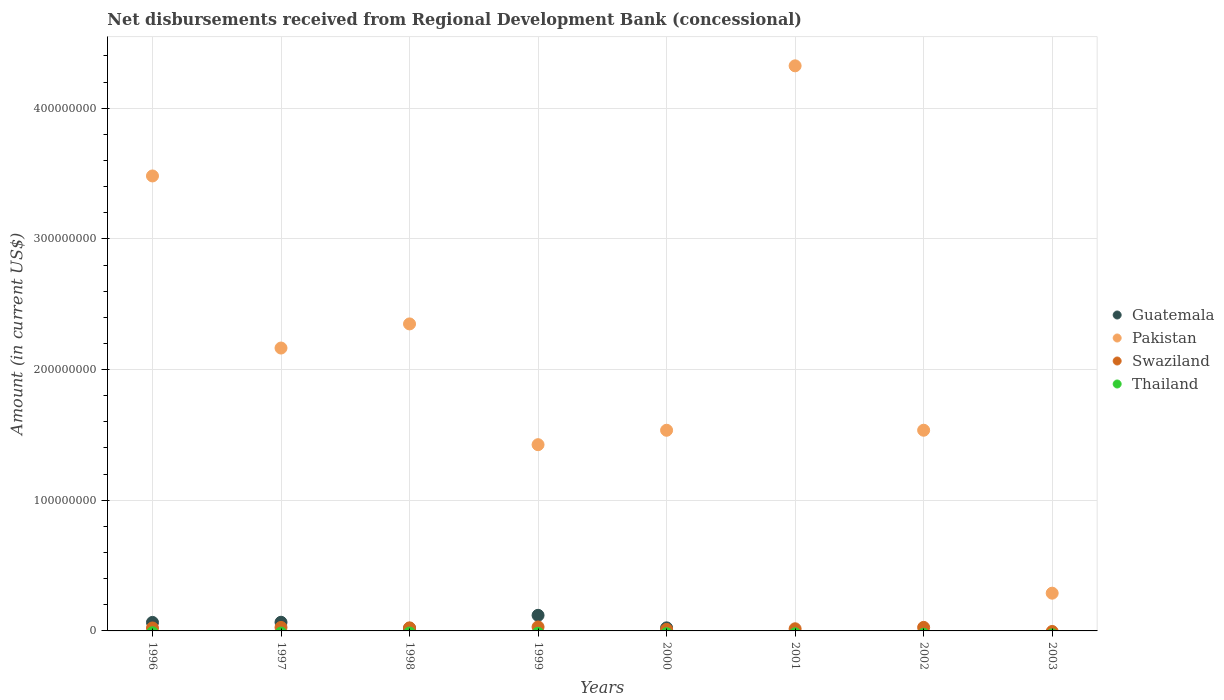How many different coloured dotlines are there?
Make the answer very short. 3. What is the amount of disbursements received from Regional Development Bank in Swaziland in 2001?
Your answer should be compact. 1.64e+06. Across all years, what is the maximum amount of disbursements received from Regional Development Bank in Pakistan?
Your answer should be compact. 4.32e+08. Across all years, what is the minimum amount of disbursements received from Regional Development Bank in Thailand?
Your response must be concise. 0. In which year was the amount of disbursements received from Regional Development Bank in Pakistan maximum?
Give a very brief answer. 2001. What is the difference between the amount of disbursements received from Regional Development Bank in Swaziland in 1996 and that in 2000?
Provide a short and direct response. 1.06e+06. What is the difference between the amount of disbursements received from Regional Development Bank in Swaziland in 1997 and the amount of disbursements received from Regional Development Bank in Pakistan in 1999?
Keep it short and to the point. -1.40e+08. In the year 1999, what is the difference between the amount of disbursements received from Regional Development Bank in Swaziland and amount of disbursements received from Regional Development Bank in Guatemala?
Your response must be concise. -8.90e+06. In how many years, is the amount of disbursements received from Regional Development Bank in Swaziland greater than 180000000 US$?
Your answer should be compact. 0. What is the ratio of the amount of disbursements received from Regional Development Bank in Pakistan in 1996 to that in 1998?
Keep it short and to the point. 1.48. Is the amount of disbursements received from Regional Development Bank in Pakistan in 1997 less than that in 2000?
Give a very brief answer. No. Is the difference between the amount of disbursements received from Regional Development Bank in Swaziland in 1996 and 1999 greater than the difference between the amount of disbursements received from Regional Development Bank in Guatemala in 1996 and 1999?
Provide a succinct answer. Yes. What is the difference between the highest and the second highest amount of disbursements received from Regional Development Bank in Swaziland?
Offer a terse response. 3.47e+05. What is the difference between the highest and the lowest amount of disbursements received from Regional Development Bank in Swaziland?
Ensure brevity in your answer.  3.04e+06. Is the sum of the amount of disbursements received from Regional Development Bank in Guatemala in 1996 and 2000 greater than the maximum amount of disbursements received from Regional Development Bank in Pakistan across all years?
Make the answer very short. No. Is the amount of disbursements received from Regional Development Bank in Thailand strictly greater than the amount of disbursements received from Regional Development Bank in Guatemala over the years?
Provide a succinct answer. No. How many dotlines are there?
Your answer should be very brief. 3. How many years are there in the graph?
Offer a very short reply. 8. Does the graph contain any zero values?
Keep it short and to the point. Yes. Where does the legend appear in the graph?
Your answer should be compact. Center right. What is the title of the graph?
Provide a succinct answer. Net disbursements received from Regional Development Bank (concessional). What is the label or title of the X-axis?
Offer a terse response. Years. What is the Amount (in current US$) in Guatemala in 1996?
Keep it short and to the point. 6.51e+06. What is the Amount (in current US$) of Pakistan in 1996?
Keep it short and to the point. 3.48e+08. What is the Amount (in current US$) in Swaziland in 1996?
Provide a short and direct response. 2.25e+06. What is the Amount (in current US$) of Guatemala in 1997?
Keep it short and to the point. 6.62e+06. What is the Amount (in current US$) in Pakistan in 1997?
Offer a very short reply. 2.16e+08. What is the Amount (in current US$) in Swaziland in 1997?
Provide a succinct answer. 2.66e+06. What is the Amount (in current US$) of Thailand in 1997?
Your answer should be compact. 0. What is the Amount (in current US$) of Guatemala in 1998?
Provide a short and direct response. 1.99e+06. What is the Amount (in current US$) in Pakistan in 1998?
Your answer should be very brief. 2.35e+08. What is the Amount (in current US$) in Swaziland in 1998?
Your answer should be compact. 2.34e+06. What is the Amount (in current US$) in Guatemala in 1999?
Offer a terse response. 1.19e+07. What is the Amount (in current US$) in Pakistan in 1999?
Provide a short and direct response. 1.43e+08. What is the Amount (in current US$) of Swaziland in 1999?
Provide a short and direct response. 3.04e+06. What is the Amount (in current US$) in Guatemala in 2000?
Offer a terse response. 2.35e+06. What is the Amount (in current US$) of Pakistan in 2000?
Provide a succinct answer. 1.54e+08. What is the Amount (in current US$) in Swaziland in 2000?
Offer a terse response. 1.19e+06. What is the Amount (in current US$) in Pakistan in 2001?
Offer a terse response. 4.32e+08. What is the Amount (in current US$) of Swaziland in 2001?
Offer a terse response. 1.64e+06. What is the Amount (in current US$) in Thailand in 2001?
Your answer should be very brief. 0. What is the Amount (in current US$) of Guatemala in 2002?
Give a very brief answer. 0. What is the Amount (in current US$) of Pakistan in 2002?
Your answer should be compact. 1.54e+08. What is the Amount (in current US$) of Swaziland in 2002?
Give a very brief answer. 2.70e+06. What is the Amount (in current US$) of Thailand in 2002?
Offer a very short reply. 0. What is the Amount (in current US$) in Pakistan in 2003?
Provide a succinct answer. 2.89e+07. What is the Amount (in current US$) in Swaziland in 2003?
Keep it short and to the point. 0. What is the Amount (in current US$) in Thailand in 2003?
Your response must be concise. 0. Across all years, what is the maximum Amount (in current US$) of Guatemala?
Provide a succinct answer. 1.19e+07. Across all years, what is the maximum Amount (in current US$) in Pakistan?
Your answer should be compact. 4.32e+08. Across all years, what is the maximum Amount (in current US$) in Swaziland?
Offer a terse response. 3.04e+06. Across all years, what is the minimum Amount (in current US$) in Pakistan?
Make the answer very short. 2.89e+07. Across all years, what is the minimum Amount (in current US$) of Swaziland?
Provide a succinct answer. 0. What is the total Amount (in current US$) of Guatemala in the graph?
Offer a very short reply. 2.94e+07. What is the total Amount (in current US$) of Pakistan in the graph?
Provide a short and direct response. 1.71e+09. What is the total Amount (in current US$) of Swaziland in the graph?
Provide a short and direct response. 1.58e+07. What is the difference between the Amount (in current US$) of Guatemala in 1996 and that in 1997?
Make the answer very short. -1.18e+05. What is the difference between the Amount (in current US$) in Pakistan in 1996 and that in 1997?
Make the answer very short. 1.32e+08. What is the difference between the Amount (in current US$) in Swaziland in 1996 and that in 1997?
Offer a terse response. -4.10e+05. What is the difference between the Amount (in current US$) of Guatemala in 1996 and that in 1998?
Your response must be concise. 4.51e+06. What is the difference between the Amount (in current US$) in Pakistan in 1996 and that in 1998?
Offer a terse response. 1.13e+08. What is the difference between the Amount (in current US$) in Swaziland in 1996 and that in 1998?
Your answer should be compact. -9.20e+04. What is the difference between the Amount (in current US$) of Guatemala in 1996 and that in 1999?
Make the answer very short. -5.44e+06. What is the difference between the Amount (in current US$) of Pakistan in 1996 and that in 1999?
Offer a terse response. 2.06e+08. What is the difference between the Amount (in current US$) of Swaziland in 1996 and that in 1999?
Provide a short and direct response. -7.90e+05. What is the difference between the Amount (in current US$) in Guatemala in 1996 and that in 2000?
Your answer should be compact. 4.16e+06. What is the difference between the Amount (in current US$) in Pakistan in 1996 and that in 2000?
Ensure brevity in your answer.  1.95e+08. What is the difference between the Amount (in current US$) of Swaziland in 1996 and that in 2000?
Keep it short and to the point. 1.06e+06. What is the difference between the Amount (in current US$) of Pakistan in 1996 and that in 2001?
Your answer should be compact. -8.43e+07. What is the difference between the Amount (in current US$) in Swaziland in 1996 and that in 2001?
Provide a succinct answer. 6.12e+05. What is the difference between the Amount (in current US$) in Pakistan in 1996 and that in 2002?
Ensure brevity in your answer.  1.95e+08. What is the difference between the Amount (in current US$) of Swaziland in 1996 and that in 2002?
Give a very brief answer. -4.43e+05. What is the difference between the Amount (in current US$) in Pakistan in 1996 and that in 2003?
Give a very brief answer. 3.19e+08. What is the difference between the Amount (in current US$) of Guatemala in 1997 and that in 1998?
Make the answer very short. 4.63e+06. What is the difference between the Amount (in current US$) of Pakistan in 1997 and that in 1998?
Your answer should be very brief. -1.85e+07. What is the difference between the Amount (in current US$) of Swaziland in 1997 and that in 1998?
Give a very brief answer. 3.18e+05. What is the difference between the Amount (in current US$) of Guatemala in 1997 and that in 1999?
Make the answer very short. -5.32e+06. What is the difference between the Amount (in current US$) of Pakistan in 1997 and that in 1999?
Provide a short and direct response. 7.40e+07. What is the difference between the Amount (in current US$) of Swaziland in 1997 and that in 1999?
Offer a terse response. -3.80e+05. What is the difference between the Amount (in current US$) of Guatemala in 1997 and that in 2000?
Your answer should be very brief. 4.28e+06. What is the difference between the Amount (in current US$) of Pakistan in 1997 and that in 2000?
Keep it short and to the point. 6.29e+07. What is the difference between the Amount (in current US$) in Swaziland in 1997 and that in 2000?
Keep it short and to the point. 1.47e+06. What is the difference between the Amount (in current US$) of Pakistan in 1997 and that in 2001?
Offer a terse response. -2.16e+08. What is the difference between the Amount (in current US$) in Swaziland in 1997 and that in 2001?
Offer a very short reply. 1.02e+06. What is the difference between the Amount (in current US$) in Pakistan in 1997 and that in 2002?
Your answer should be very brief. 6.29e+07. What is the difference between the Amount (in current US$) of Swaziland in 1997 and that in 2002?
Make the answer very short. -3.30e+04. What is the difference between the Amount (in current US$) of Pakistan in 1997 and that in 2003?
Give a very brief answer. 1.88e+08. What is the difference between the Amount (in current US$) of Guatemala in 1998 and that in 1999?
Your response must be concise. -9.95e+06. What is the difference between the Amount (in current US$) of Pakistan in 1998 and that in 1999?
Keep it short and to the point. 9.24e+07. What is the difference between the Amount (in current US$) of Swaziland in 1998 and that in 1999?
Your answer should be compact. -6.98e+05. What is the difference between the Amount (in current US$) in Guatemala in 1998 and that in 2000?
Keep it short and to the point. -3.56e+05. What is the difference between the Amount (in current US$) in Pakistan in 1998 and that in 2000?
Provide a succinct answer. 8.14e+07. What is the difference between the Amount (in current US$) of Swaziland in 1998 and that in 2000?
Give a very brief answer. 1.15e+06. What is the difference between the Amount (in current US$) in Pakistan in 1998 and that in 2001?
Your answer should be compact. -1.98e+08. What is the difference between the Amount (in current US$) of Swaziland in 1998 and that in 2001?
Offer a terse response. 7.04e+05. What is the difference between the Amount (in current US$) of Pakistan in 1998 and that in 2002?
Give a very brief answer. 8.14e+07. What is the difference between the Amount (in current US$) of Swaziland in 1998 and that in 2002?
Ensure brevity in your answer.  -3.51e+05. What is the difference between the Amount (in current US$) of Pakistan in 1998 and that in 2003?
Offer a very short reply. 2.06e+08. What is the difference between the Amount (in current US$) in Guatemala in 1999 and that in 2000?
Your response must be concise. 9.60e+06. What is the difference between the Amount (in current US$) of Pakistan in 1999 and that in 2000?
Your response must be concise. -1.10e+07. What is the difference between the Amount (in current US$) of Swaziland in 1999 and that in 2000?
Your response must be concise. 1.85e+06. What is the difference between the Amount (in current US$) in Pakistan in 1999 and that in 2001?
Ensure brevity in your answer.  -2.90e+08. What is the difference between the Amount (in current US$) of Swaziland in 1999 and that in 2001?
Make the answer very short. 1.40e+06. What is the difference between the Amount (in current US$) in Pakistan in 1999 and that in 2002?
Provide a succinct answer. -1.11e+07. What is the difference between the Amount (in current US$) of Swaziland in 1999 and that in 2002?
Offer a very short reply. 3.47e+05. What is the difference between the Amount (in current US$) of Pakistan in 1999 and that in 2003?
Your answer should be very brief. 1.14e+08. What is the difference between the Amount (in current US$) of Pakistan in 2000 and that in 2001?
Make the answer very short. -2.79e+08. What is the difference between the Amount (in current US$) of Swaziland in 2000 and that in 2001?
Give a very brief answer. -4.48e+05. What is the difference between the Amount (in current US$) in Pakistan in 2000 and that in 2002?
Ensure brevity in your answer.  -1.80e+04. What is the difference between the Amount (in current US$) in Swaziland in 2000 and that in 2002?
Give a very brief answer. -1.50e+06. What is the difference between the Amount (in current US$) in Pakistan in 2000 and that in 2003?
Your answer should be very brief. 1.25e+08. What is the difference between the Amount (in current US$) in Pakistan in 2001 and that in 2002?
Provide a succinct answer. 2.79e+08. What is the difference between the Amount (in current US$) in Swaziland in 2001 and that in 2002?
Your response must be concise. -1.06e+06. What is the difference between the Amount (in current US$) of Pakistan in 2001 and that in 2003?
Offer a very short reply. 4.04e+08. What is the difference between the Amount (in current US$) in Pakistan in 2002 and that in 2003?
Your response must be concise. 1.25e+08. What is the difference between the Amount (in current US$) in Guatemala in 1996 and the Amount (in current US$) in Pakistan in 1997?
Make the answer very short. -2.10e+08. What is the difference between the Amount (in current US$) in Guatemala in 1996 and the Amount (in current US$) in Swaziland in 1997?
Your answer should be compact. 3.84e+06. What is the difference between the Amount (in current US$) in Pakistan in 1996 and the Amount (in current US$) in Swaziland in 1997?
Keep it short and to the point. 3.46e+08. What is the difference between the Amount (in current US$) in Guatemala in 1996 and the Amount (in current US$) in Pakistan in 1998?
Provide a short and direct response. -2.28e+08. What is the difference between the Amount (in current US$) in Guatemala in 1996 and the Amount (in current US$) in Swaziland in 1998?
Keep it short and to the point. 4.16e+06. What is the difference between the Amount (in current US$) of Pakistan in 1996 and the Amount (in current US$) of Swaziland in 1998?
Your response must be concise. 3.46e+08. What is the difference between the Amount (in current US$) in Guatemala in 1996 and the Amount (in current US$) in Pakistan in 1999?
Your answer should be very brief. -1.36e+08. What is the difference between the Amount (in current US$) of Guatemala in 1996 and the Amount (in current US$) of Swaziland in 1999?
Provide a succinct answer. 3.46e+06. What is the difference between the Amount (in current US$) in Pakistan in 1996 and the Amount (in current US$) in Swaziland in 1999?
Keep it short and to the point. 3.45e+08. What is the difference between the Amount (in current US$) in Guatemala in 1996 and the Amount (in current US$) in Pakistan in 2000?
Make the answer very short. -1.47e+08. What is the difference between the Amount (in current US$) in Guatemala in 1996 and the Amount (in current US$) in Swaziland in 2000?
Offer a very short reply. 5.32e+06. What is the difference between the Amount (in current US$) in Pakistan in 1996 and the Amount (in current US$) in Swaziland in 2000?
Keep it short and to the point. 3.47e+08. What is the difference between the Amount (in current US$) in Guatemala in 1996 and the Amount (in current US$) in Pakistan in 2001?
Keep it short and to the point. -4.26e+08. What is the difference between the Amount (in current US$) in Guatemala in 1996 and the Amount (in current US$) in Swaziland in 2001?
Make the answer very short. 4.87e+06. What is the difference between the Amount (in current US$) of Pakistan in 1996 and the Amount (in current US$) of Swaziland in 2001?
Give a very brief answer. 3.47e+08. What is the difference between the Amount (in current US$) of Guatemala in 1996 and the Amount (in current US$) of Pakistan in 2002?
Make the answer very short. -1.47e+08. What is the difference between the Amount (in current US$) of Guatemala in 1996 and the Amount (in current US$) of Swaziland in 2002?
Give a very brief answer. 3.81e+06. What is the difference between the Amount (in current US$) in Pakistan in 1996 and the Amount (in current US$) in Swaziland in 2002?
Offer a very short reply. 3.45e+08. What is the difference between the Amount (in current US$) of Guatemala in 1996 and the Amount (in current US$) of Pakistan in 2003?
Offer a very short reply. -2.24e+07. What is the difference between the Amount (in current US$) of Guatemala in 1997 and the Amount (in current US$) of Pakistan in 1998?
Your answer should be compact. -2.28e+08. What is the difference between the Amount (in current US$) in Guatemala in 1997 and the Amount (in current US$) in Swaziland in 1998?
Provide a succinct answer. 4.28e+06. What is the difference between the Amount (in current US$) of Pakistan in 1997 and the Amount (in current US$) of Swaziland in 1998?
Your answer should be very brief. 2.14e+08. What is the difference between the Amount (in current US$) of Guatemala in 1997 and the Amount (in current US$) of Pakistan in 1999?
Ensure brevity in your answer.  -1.36e+08. What is the difference between the Amount (in current US$) in Guatemala in 1997 and the Amount (in current US$) in Swaziland in 1999?
Offer a terse response. 3.58e+06. What is the difference between the Amount (in current US$) of Pakistan in 1997 and the Amount (in current US$) of Swaziland in 1999?
Your answer should be very brief. 2.13e+08. What is the difference between the Amount (in current US$) in Guatemala in 1997 and the Amount (in current US$) in Pakistan in 2000?
Your response must be concise. -1.47e+08. What is the difference between the Amount (in current US$) of Guatemala in 1997 and the Amount (in current US$) of Swaziland in 2000?
Keep it short and to the point. 5.43e+06. What is the difference between the Amount (in current US$) in Pakistan in 1997 and the Amount (in current US$) in Swaziland in 2000?
Ensure brevity in your answer.  2.15e+08. What is the difference between the Amount (in current US$) of Guatemala in 1997 and the Amount (in current US$) of Pakistan in 2001?
Your answer should be compact. -4.26e+08. What is the difference between the Amount (in current US$) in Guatemala in 1997 and the Amount (in current US$) in Swaziland in 2001?
Keep it short and to the point. 4.98e+06. What is the difference between the Amount (in current US$) of Pakistan in 1997 and the Amount (in current US$) of Swaziland in 2001?
Make the answer very short. 2.15e+08. What is the difference between the Amount (in current US$) of Guatemala in 1997 and the Amount (in current US$) of Pakistan in 2002?
Your answer should be compact. -1.47e+08. What is the difference between the Amount (in current US$) in Guatemala in 1997 and the Amount (in current US$) in Swaziland in 2002?
Give a very brief answer. 3.93e+06. What is the difference between the Amount (in current US$) of Pakistan in 1997 and the Amount (in current US$) of Swaziland in 2002?
Ensure brevity in your answer.  2.14e+08. What is the difference between the Amount (in current US$) of Guatemala in 1997 and the Amount (in current US$) of Pakistan in 2003?
Provide a short and direct response. -2.23e+07. What is the difference between the Amount (in current US$) of Guatemala in 1998 and the Amount (in current US$) of Pakistan in 1999?
Offer a very short reply. -1.41e+08. What is the difference between the Amount (in current US$) of Guatemala in 1998 and the Amount (in current US$) of Swaziland in 1999?
Provide a succinct answer. -1.05e+06. What is the difference between the Amount (in current US$) in Pakistan in 1998 and the Amount (in current US$) in Swaziland in 1999?
Keep it short and to the point. 2.32e+08. What is the difference between the Amount (in current US$) in Guatemala in 1998 and the Amount (in current US$) in Pakistan in 2000?
Your answer should be very brief. -1.52e+08. What is the difference between the Amount (in current US$) in Guatemala in 1998 and the Amount (in current US$) in Swaziland in 2000?
Your answer should be compact. 8.01e+05. What is the difference between the Amount (in current US$) of Pakistan in 1998 and the Amount (in current US$) of Swaziland in 2000?
Your answer should be very brief. 2.34e+08. What is the difference between the Amount (in current US$) of Guatemala in 1998 and the Amount (in current US$) of Pakistan in 2001?
Keep it short and to the point. -4.30e+08. What is the difference between the Amount (in current US$) of Guatemala in 1998 and the Amount (in current US$) of Swaziland in 2001?
Your response must be concise. 3.53e+05. What is the difference between the Amount (in current US$) in Pakistan in 1998 and the Amount (in current US$) in Swaziland in 2001?
Make the answer very short. 2.33e+08. What is the difference between the Amount (in current US$) of Guatemala in 1998 and the Amount (in current US$) of Pakistan in 2002?
Provide a succinct answer. -1.52e+08. What is the difference between the Amount (in current US$) in Guatemala in 1998 and the Amount (in current US$) in Swaziland in 2002?
Provide a short and direct response. -7.02e+05. What is the difference between the Amount (in current US$) of Pakistan in 1998 and the Amount (in current US$) of Swaziland in 2002?
Your answer should be compact. 2.32e+08. What is the difference between the Amount (in current US$) in Guatemala in 1998 and the Amount (in current US$) in Pakistan in 2003?
Keep it short and to the point. -2.69e+07. What is the difference between the Amount (in current US$) of Guatemala in 1999 and the Amount (in current US$) of Pakistan in 2000?
Offer a terse response. -1.42e+08. What is the difference between the Amount (in current US$) of Guatemala in 1999 and the Amount (in current US$) of Swaziland in 2000?
Keep it short and to the point. 1.08e+07. What is the difference between the Amount (in current US$) in Pakistan in 1999 and the Amount (in current US$) in Swaziland in 2000?
Your answer should be compact. 1.41e+08. What is the difference between the Amount (in current US$) of Guatemala in 1999 and the Amount (in current US$) of Pakistan in 2001?
Keep it short and to the point. -4.21e+08. What is the difference between the Amount (in current US$) of Guatemala in 1999 and the Amount (in current US$) of Swaziland in 2001?
Your response must be concise. 1.03e+07. What is the difference between the Amount (in current US$) in Pakistan in 1999 and the Amount (in current US$) in Swaziland in 2001?
Your response must be concise. 1.41e+08. What is the difference between the Amount (in current US$) in Guatemala in 1999 and the Amount (in current US$) in Pakistan in 2002?
Make the answer very short. -1.42e+08. What is the difference between the Amount (in current US$) of Guatemala in 1999 and the Amount (in current US$) of Swaziland in 2002?
Your answer should be compact. 9.25e+06. What is the difference between the Amount (in current US$) of Pakistan in 1999 and the Amount (in current US$) of Swaziland in 2002?
Keep it short and to the point. 1.40e+08. What is the difference between the Amount (in current US$) in Guatemala in 1999 and the Amount (in current US$) in Pakistan in 2003?
Your answer should be very brief. -1.69e+07. What is the difference between the Amount (in current US$) of Guatemala in 2000 and the Amount (in current US$) of Pakistan in 2001?
Your answer should be compact. -4.30e+08. What is the difference between the Amount (in current US$) of Guatemala in 2000 and the Amount (in current US$) of Swaziland in 2001?
Ensure brevity in your answer.  7.09e+05. What is the difference between the Amount (in current US$) in Pakistan in 2000 and the Amount (in current US$) in Swaziland in 2001?
Your response must be concise. 1.52e+08. What is the difference between the Amount (in current US$) of Guatemala in 2000 and the Amount (in current US$) of Pakistan in 2002?
Offer a very short reply. -1.51e+08. What is the difference between the Amount (in current US$) of Guatemala in 2000 and the Amount (in current US$) of Swaziland in 2002?
Provide a succinct answer. -3.46e+05. What is the difference between the Amount (in current US$) of Pakistan in 2000 and the Amount (in current US$) of Swaziland in 2002?
Your response must be concise. 1.51e+08. What is the difference between the Amount (in current US$) of Guatemala in 2000 and the Amount (in current US$) of Pakistan in 2003?
Ensure brevity in your answer.  -2.65e+07. What is the difference between the Amount (in current US$) of Pakistan in 2001 and the Amount (in current US$) of Swaziland in 2002?
Ensure brevity in your answer.  4.30e+08. What is the average Amount (in current US$) of Guatemala per year?
Your response must be concise. 3.68e+06. What is the average Amount (in current US$) in Pakistan per year?
Offer a very short reply. 2.14e+08. What is the average Amount (in current US$) in Swaziland per year?
Offer a very short reply. 1.98e+06. In the year 1996, what is the difference between the Amount (in current US$) in Guatemala and Amount (in current US$) in Pakistan?
Offer a very short reply. -3.42e+08. In the year 1996, what is the difference between the Amount (in current US$) in Guatemala and Amount (in current US$) in Swaziland?
Provide a short and direct response. 4.26e+06. In the year 1996, what is the difference between the Amount (in current US$) of Pakistan and Amount (in current US$) of Swaziland?
Offer a terse response. 3.46e+08. In the year 1997, what is the difference between the Amount (in current US$) of Guatemala and Amount (in current US$) of Pakistan?
Your response must be concise. -2.10e+08. In the year 1997, what is the difference between the Amount (in current US$) in Guatemala and Amount (in current US$) in Swaziland?
Ensure brevity in your answer.  3.96e+06. In the year 1997, what is the difference between the Amount (in current US$) in Pakistan and Amount (in current US$) in Swaziland?
Offer a terse response. 2.14e+08. In the year 1998, what is the difference between the Amount (in current US$) in Guatemala and Amount (in current US$) in Pakistan?
Offer a terse response. -2.33e+08. In the year 1998, what is the difference between the Amount (in current US$) in Guatemala and Amount (in current US$) in Swaziland?
Your response must be concise. -3.51e+05. In the year 1998, what is the difference between the Amount (in current US$) of Pakistan and Amount (in current US$) of Swaziland?
Your response must be concise. 2.33e+08. In the year 1999, what is the difference between the Amount (in current US$) in Guatemala and Amount (in current US$) in Pakistan?
Provide a succinct answer. -1.31e+08. In the year 1999, what is the difference between the Amount (in current US$) of Guatemala and Amount (in current US$) of Swaziland?
Your answer should be very brief. 8.90e+06. In the year 1999, what is the difference between the Amount (in current US$) of Pakistan and Amount (in current US$) of Swaziland?
Ensure brevity in your answer.  1.39e+08. In the year 2000, what is the difference between the Amount (in current US$) of Guatemala and Amount (in current US$) of Pakistan?
Keep it short and to the point. -1.51e+08. In the year 2000, what is the difference between the Amount (in current US$) of Guatemala and Amount (in current US$) of Swaziland?
Your answer should be compact. 1.16e+06. In the year 2000, what is the difference between the Amount (in current US$) of Pakistan and Amount (in current US$) of Swaziland?
Provide a short and direct response. 1.52e+08. In the year 2001, what is the difference between the Amount (in current US$) in Pakistan and Amount (in current US$) in Swaziland?
Keep it short and to the point. 4.31e+08. In the year 2002, what is the difference between the Amount (in current US$) of Pakistan and Amount (in current US$) of Swaziland?
Offer a terse response. 1.51e+08. What is the ratio of the Amount (in current US$) in Guatemala in 1996 to that in 1997?
Provide a succinct answer. 0.98. What is the ratio of the Amount (in current US$) in Pakistan in 1996 to that in 1997?
Your answer should be very brief. 1.61. What is the ratio of the Amount (in current US$) in Swaziland in 1996 to that in 1997?
Your answer should be compact. 0.85. What is the ratio of the Amount (in current US$) of Guatemala in 1996 to that in 1998?
Offer a very short reply. 3.26. What is the ratio of the Amount (in current US$) of Pakistan in 1996 to that in 1998?
Your response must be concise. 1.48. What is the ratio of the Amount (in current US$) of Swaziland in 1996 to that in 1998?
Provide a succinct answer. 0.96. What is the ratio of the Amount (in current US$) of Guatemala in 1996 to that in 1999?
Keep it short and to the point. 0.54. What is the ratio of the Amount (in current US$) in Pakistan in 1996 to that in 1999?
Your answer should be very brief. 2.44. What is the ratio of the Amount (in current US$) of Swaziland in 1996 to that in 1999?
Keep it short and to the point. 0.74. What is the ratio of the Amount (in current US$) of Guatemala in 1996 to that in 2000?
Ensure brevity in your answer.  2.77. What is the ratio of the Amount (in current US$) of Pakistan in 1996 to that in 2000?
Make the answer very short. 2.27. What is the ratio of the Amount (in current US$) in Swaziland in 1996 to that in 2000?
Ensure brevity in your answer.  1.89. What is the ratio of the Amount (in current US$) of Pakistan in 1996 to that in 2001?
Give a very brief answer. 0.81. What is the ratio of the Amount (in current US$) of Swaziland in 1996 to that in 2001?
Ensure brevity in your answer.  1.37. What is the ratio of the Amount (in current US$) of Pakistan in 1996 to that in 2002?
Your answer should be very brief. 2.27. What is the ratio of the Amount (in current US$) in Swaziland in 1996 to that in 2002?
Offer a terse response. 0.84. What is the ratio of the Amount (in current US$) of Pakistan in 1996 to that in 2003?
Make the answer very short. 12.06. What is the ratio of the Amount (in current US$) in Guatemala in 1997 to that in 1998?
Your answer should be compact. 3.32. What is the ratio of the Amount (in current US$) in Pakistan in 1997 to that in 1998?
Give a very brief answer. 0.92. What is the ratio of the Amount (in current US$) of Swaziland in 1997 to that in 1998?
Make the answer very short. 1.14. What is the ratio of the Amount (in current US$) in Guatemala in 1997 to that in 1999?
Ensure brevity in your answer.  0.55. What is the ratio of the Amount (in current US$) in Pakistan in 1997 to that in 1999?
Offer a terse response. 1.52. What is the ratio of the Amount (in current US$) in Swaziland in 1997 to that in 1999?
Provide a short and direct response. 0.88. What is the ratio of the Amount (in current US$) of Guatemala in 1997 to that in 2000?
Ensure brevity in your answer.  2.82. What is the ratio of the Amount (in current US$) in Pakistan in 1997 to that in 2000?
Keep it short and to the point. 1.41. What is the ratio of the Amount (in current US$) of Swaziland in 1997 to that in 2000?
Provide a short and direct response. 2.23. What is the ratio of the Amount (in current US$) in Pakistan in 1997 to that in 2001?
Keep it short and to the point. 0.5. What is the ratio of the Amount (in current US$) of Swaziland in 1997 to that in 2001?
Your answer should be very brief. 1.62. What is the ratio of the Amount (in current US$) in Pakistan in 1997 to that in 2002?
Offer a very short reply. 1.41. What is the ratio of the Amount (in current US$) of Swaziland in 1997 to that in 2002?
Make the answer very short. 0.99. What is the ratio of the Amount (in current US$) of Pakistan in 1997 to that in 2003?
Offer a terse response. 7.5. What is the ratio of the Amount (in current US$) in Guatemala in 1998 to that in 1999?
Make the answer very short. 0.17. What is the ratio of the Amount (in current US$) of Pakistan in 1998 to that in 1999?
Your answer should be compact. 1.65. What is the ratio of the Amount (in current US$) of Swaziland in 1998 to that in 1999?
Offer a terse response. 0.77. What is the ratio of the Amount (in current US$) of Guatemala in 1998 to that in 2000?
Offer a terse response. 0.85. What is the ratio of the Amount (in current US$) of Pakistan in 1998 to that in 2000?
Make the answer very short. 1.53. What is the ratio of the Amount (in current US$) in Swaziland in 1998 to that in 2000?
Your response must be concise. 1.97. What is the ratio of the Amount (in current US$) in Pakistan in 1998 to that in 2001?
Ensure brevity in your answer.  0.54. What is the ratio of the Amount (in current US$) of Swaziland in 1998 to that in 2001?
Offer a very short reply. 1.43. What is the ratio of the Amount (in current US$) in Pakistan in 1998 to that in 2002?
Offer a very short reply. 1.53. What is the ratio of the Amount (in current US$) in Swaziland in 1998 to that in 2002?
Offer a very short reply. 0.87. What is the ratio of the Amount (in current US$) in Pakistan in 1998 to that in 2003?
Keep it short and to the point. 8.13. What is the ratio of the Amount (in current US$) in Guatemala in 1999 to that in 2000?
Offer a terse response. 5.08. What is the ratio of the Amount (in current US$) of Pakistan in 1999 to that in 2000?
Your answer should be compact. 0.93. What is the ratio of the Amount (in current US$) in Swaziland in 1999 to that in 2000?
Ensure brevity in your answer.  2.55. What is the ratio of the Amount (in current US$) in Pakistan in 1999 to that in 2001?
Your answer should be very brief. 0.33. What is the ratio of the Amount (in current US$) of Swaziland in 1999 to that in 2001?
Give a very brief answer. 1.85. What is the ratio of the Amount (in current US$) of Pakistan in 1999 to that in 2002?
Provide a succinct answer. 0.93. What is the ratio of the Amount (in current US$) in Swaziland in 1999 to that in 2002?
Your response must be concise. 1.13. What is the ratio of the Amount (in current US$) in Pakistan in 1999 to that in 2003?
Provide a short and direct response. 4.93. What is the ratio of the Amount (in current US$) in Pakistan in 2000 to that in 2001?
Make the answer very short. 0.36. What is the ratio of the Amount (in current US$) of Swaziland in 2000 to that in 2001?
Your answer should be very brief. 0.73. What is the ratio of the Amount (in current US$) of Pakistan in 2000 to that in 2002?
Give a very brief answer. 1. What is the ratio of the Amount (in current US$) of Swaziland in 2000 to that in 2002?
Your response must be concise. 0.44. What is the ratio of the Amount (in current US$) in Pakistan in 2000 to that in 2003?
Ensure brevity in your answer.  5.32. What is the ratio of the Amount (in current US$) in Pakistan in 2001 to that in 2002?
Give a very brief answer. 2.82. What is the ratio of the Amount (in current US$) of Swaziland in 2001 to that in 2002?
Offer a terse response. 0.61. What is the ratio of the Amount (in current US$) of Pakistan in 2001 to that in 2003?
Offer a terse response. 14.97. What is the ratio of the Amount (in current US$) in Pakistan in 2002 to that in 2003?
Offer a terse response. 5.32. What is the difference between the highest and the second highest Amount (in current US$) of Guatemala?
Your answer should be very brief. 5.32e+06. What is the difference between the highest and the second highest Amount (in current US$) in Pakistan?
Provide a short and direct response. 8.43e+07. What is the difference between the highest and the second highest Amount (in current US$) in Swaziland?
Offer a terse response. 3.47e+05. What is the difference between the highest and the lowest Amount (in current US$) in Guatemala?
Provide a short and direct response. 1.19e+07. What is the difference between the highest and the lowest Amount (in current US$) of Pakistan?
Provide a short and direct response. 4.04e+08. What is the difference between the highest and the lowest Amount (in current US$) of Swaziland?
Your answer should be very brief. 3.04e+06. 